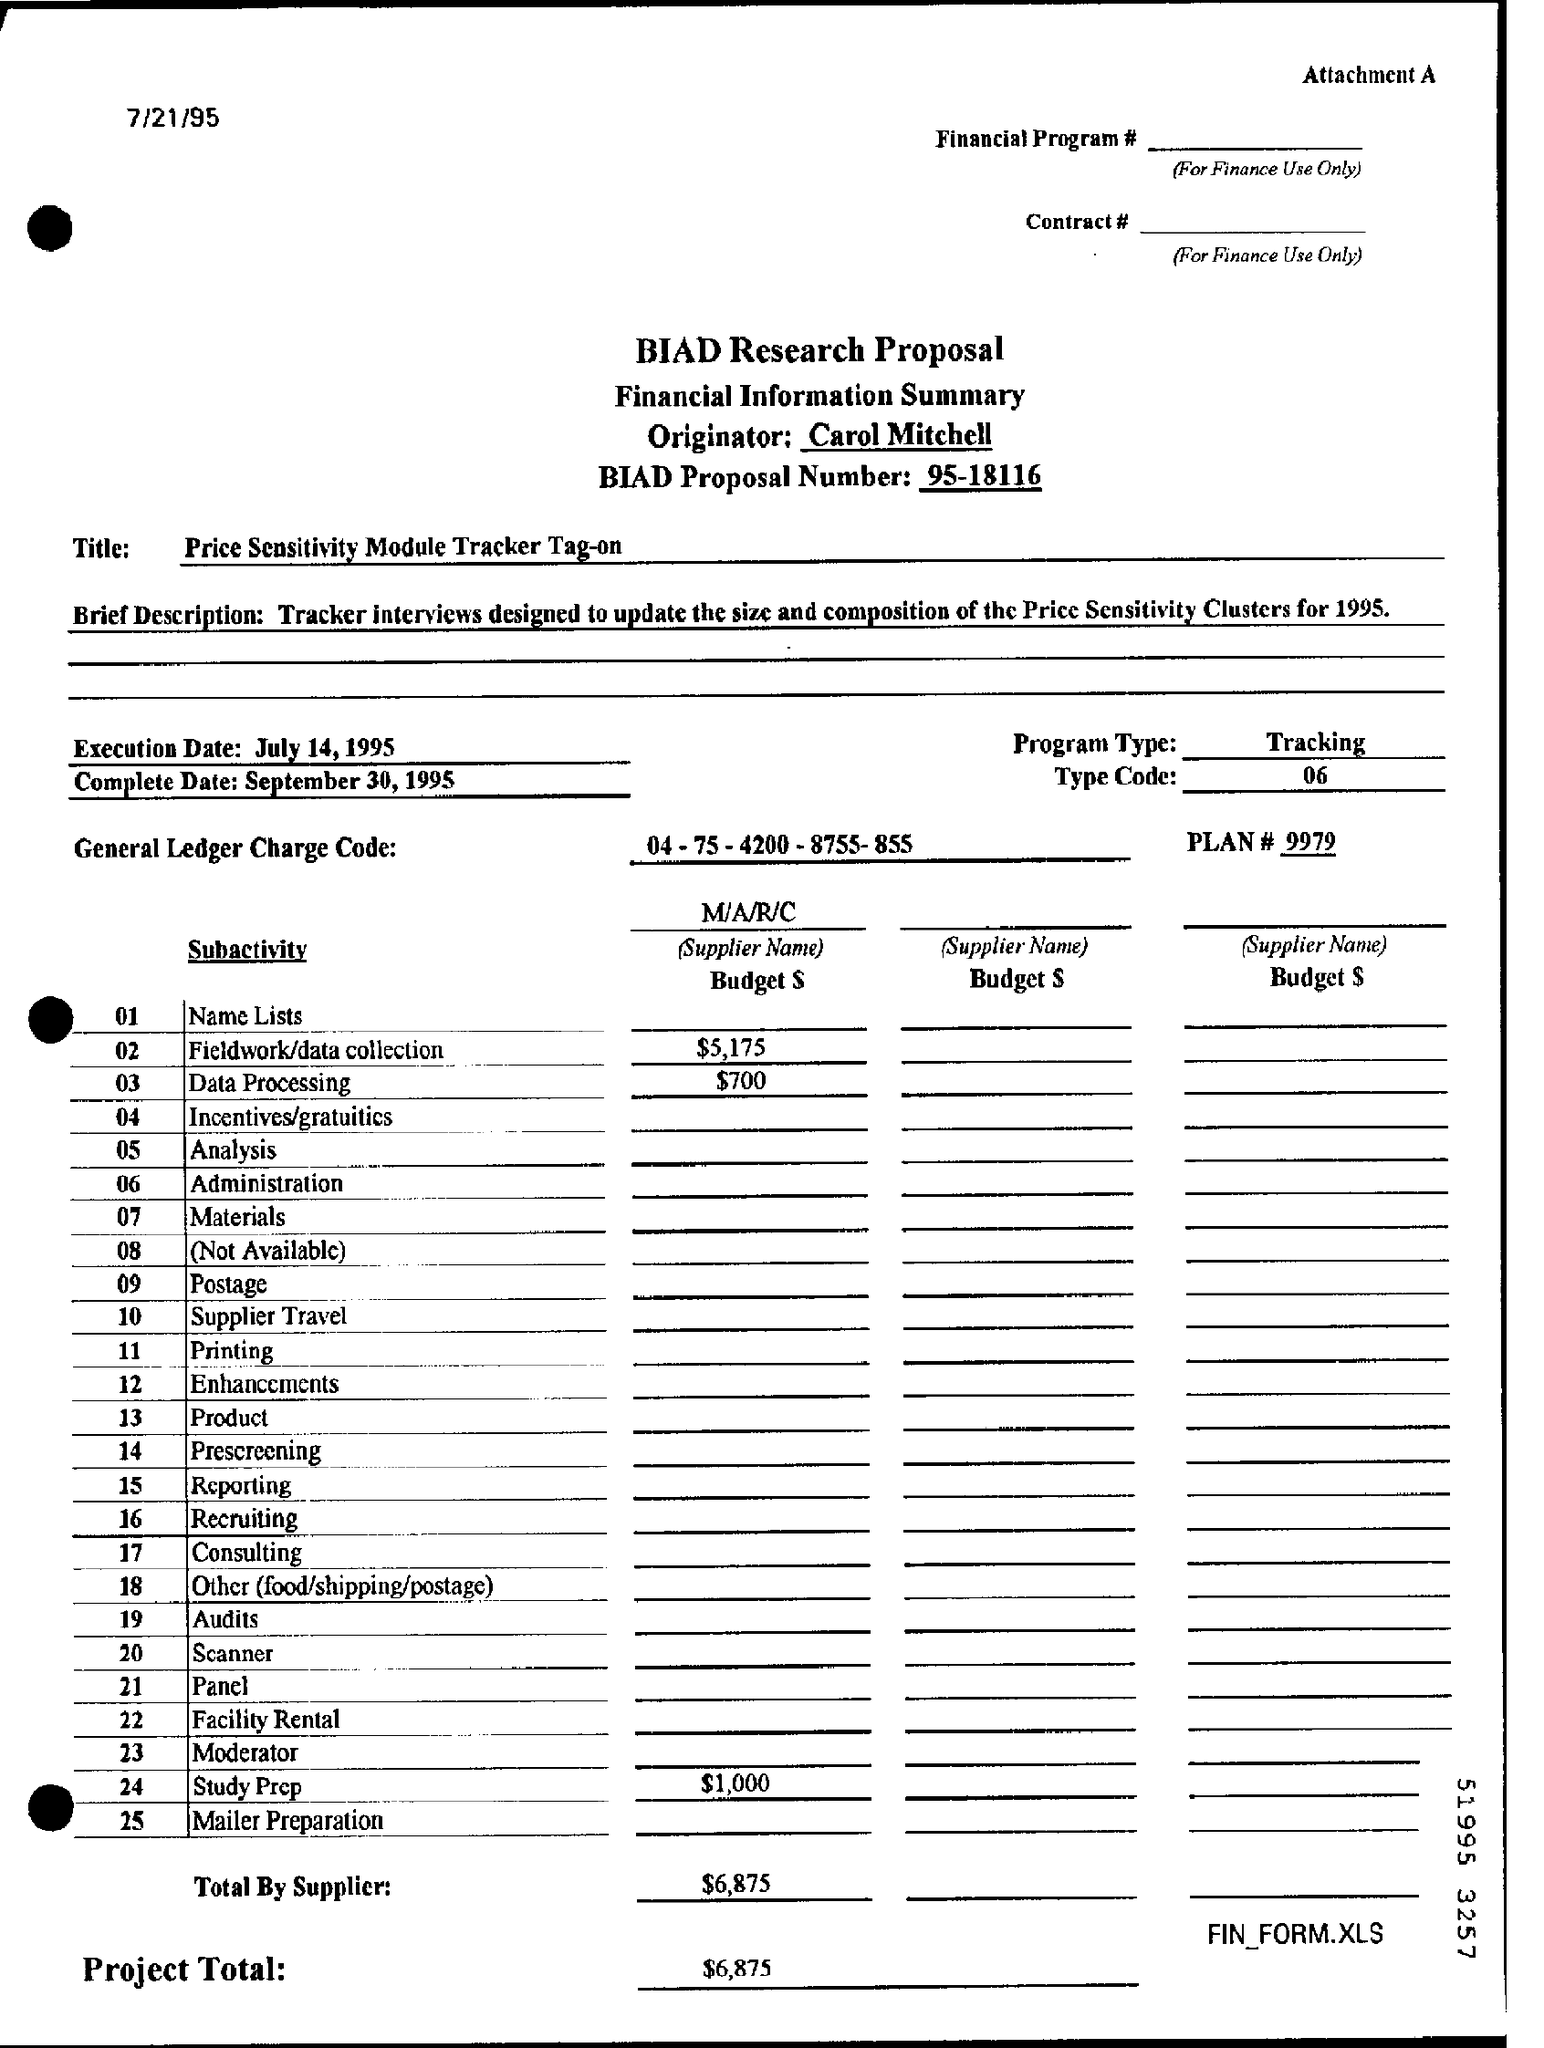Outline some significant characteristics in this image. The type code number mentioned in the proposal is 06. The BIAD Research Proposal is the name of the proposal. The program type mentioned in the proposal is "Tracking. The BIAD proposal number is 95-18116. The proposal contains a plan number, which is mentioned as # 9979. 